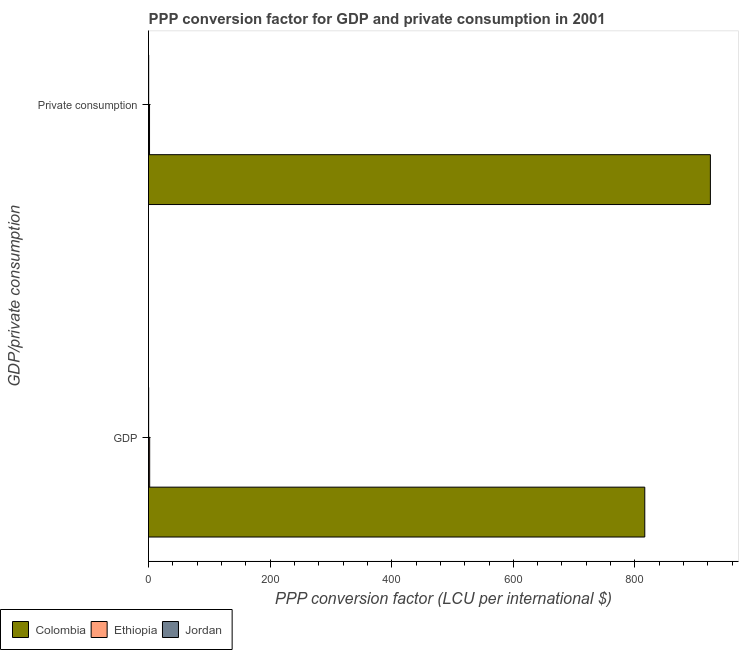Are the number of bars on each tick of the Y-axis equal?
Give a very brief answer. Yes. What is the label of the 1st group of bars from the top?
Provide a succinct answer.  Private consumption. What is the ppp conversion factor for gdp in Ethiopia?
Ensure brevity in your answer.  1.9. Across all countries, what is the maximum ppp conversion factor for private consumption?
Your response must be concise. 924.15. Across all countries, what is the minimum ppp conversion factor for gdp?
Your response must be concise. 0.2. In which country was the ppp conversion factor for private consumption minimum?
Give a very brief answer. Jordan. What is the total ppp conversion factor for private consumption in the graph?
Make the answer very short. 926.08. What is the difference between the ppp conversion factor for gdp in Colombia and that in Ethiopia?
Give a very brief answer. 814.32. What is the difference between the ppp conversion factor for private consumption in Ethiopia and the ppp conversion factor for gdp in Colombia?
Keep it short and to the point. -814.56. What is the average ppp conversion factor for private consumption per country?
Provide a short and direct response. 308.69. What is the difference between the ppp conversion factor for private consumption and ppp conversion factor for gdp in Ethiopia?
Your answer should be compact. -0.23. In how many countries, is the ppp conversion factor for private consumption greater than 600 LCU?
Your answer should be very brief. 1. What is the ratio of the ppp conversion factor for gdp in Ethiopia to that in Colombia?
Your answer should be very brief. 0. Is the ppp conversion factor for private consumption in Jordan less than that in Colombia?
Offer a very short reply. Yes. In how many countries, is the ppp conversion factor for gdp greater than the average ppp conversion factor for gdp taken over all countries?
Make the answer very short. 1. What does the 1st bar from the top in GDP represents?
Your answer should be very brief. Jordan. What does the 1st bar from the bottom in  Private consumption represents?
Your response must be concise. Colombia. How many bars are there?
Your answer should be very brief. 6. Are all the bars in the graph horizontal?
Your response must be concise. Yes. How many countries are there in the graph?
Your answer should be compact. 3. What is the difference between two consecutive major ticks on the X-axis?
Your answer should be compact. 200. Are the values on the major ticks of X-axis written in scientific E-notation?
Make the answer very short. No. Does the graph contain any zero values?
Ensure brevity in your answer.  No. Does the graph contain grids?
Offer a very short reply. No. Where does the legend appear in the graph?
Provide a short and direct response. Bottom left. What is the title of the graph?
Offer a very short reply. PPP conversion factor for GDP and private consumption in 2001. Does "Namibia" appear as one of the legend labels in the graph?
Give a very brief answer. No. What is the label or title of the X-axis?
Make the answer very short. PPP conversion factor (LCU per international $). What is the label or title of the Y-axis?
Your answer should be very brief. GDP/private consumption. What is the PPP conversion factor (LCU per international $) in Colombia in GDP?
Provide a succinct answer. 816.22. What is the PPP conversion factor (LCU per international $) in Ethiopia in GDP?
Provide a short and direct response. 1.9. What is the PPP conversion factor (LCU per international $) of Jordan in GDP?
Provide a succinct answer. 0.2. What is the PPP conversion factor (LCU per international $) of Colombia in  Private consumption?
Keep it short and to the point. 924.15. What is the PPP conversion factor (LCU per international $) in Ethiopia in  Private consumption?
Offer a terse response. 1.67. What is the PPP conversion factor (LCU per international $) of Jordan in  Private consumption?
Make the answer very short. 0.26. Across all GDP/private consumption, what is the maximum PPP conversion factor (LCU per international $) in Colombia?
Ensure brevity in your answer.  924.15. Across all GDP/private consumption, what is the maximum PPP conversion factor (LCU per international $) in Ethiopia?
Your answer should be compact. 1.9. Across all GDP/private consumption, what is the maximum PPP conversion factor (LCU per international $) of Jordan?
Your answer should be very brief. 0.26. Across all GDP/private consumption, what is the minimum PPP conversion factor (LCU per international $) in Colombia?
Keep it short and to the point. 816.22. Across all GDP/private consumption, what is the minimum PPP conversion factor (LCU per international $) of Ethiopia?
Offer a very short reply. 1.67. Across all GDP/private consumption, what is the minimum PPP conversion factor (LCU per international $) of Jordan?
Provide a short and direct response. 0.2. What is the total PPP conversion factor (LCU per international $) of Colombia in the graph?
Provide a short and direct response. 1740.37. What is the total PPP conversion factor (LCU per international $) of Ethiopia in the graph?
Your answer should be compact. 3.56. What is the total PPP conversion factor (LCU per international $) of Jordan in the graph?
Your response must be concise. 0.46. What is the difference between the PPP conversion factor (LCU per international $) of Colombia in GDP and that in  Private consumption?
Your answer should be compact. -107.93. What is the difference between the PPP conversion factor (LCU per international $) in Ethiopia in GDP and that in  Private consumption?
Offer a very short reply. 0.23. What is the difference between the PPP conversion factor (LCU per international $) in Jordan in GDP and that in  Private consumption?
Ensure brevity in your answer.  -0.06. What is the difference between the PPP conversion factor (LCU per international $) in Colombia in GDP and the PPP conversion factor (LCU per international $) in Ethiopia in  Private consumption?
Your answer should be compact. 814.56. What is the difference between the PPP conversion factor (LCU per international $) in Colombia in GDP and the PPP conversion factor (LCU per international $) in Jordan in  Private consumption?
Keep it short and to the point. 815.96. What is the difference between the PPP conversion factor (LCU per international $) in Ethiopia in GDP and the PPP conversion factor (LCU per international $) in Jordan in  Private consumption?
Keep it short and to the point. 1.64. What is the average PPP conversion factor (LCU per international $) of Colombia per GDP/private consumption?
Offer a terse response. 870.19. What is the average PPP conversion factor (LCU per international $) of Ethiopia per GDP/private consumption?
Provide a short and direct response. 1.78. What is the average PPP conversion factor (LCU per international $) in Jordan per GDP/private consumption?
Offer a very short reply. 0.23. What is the difference between the PPP conversion factor (LCU per international $) in Colombia and PPP conversion factor (LCU per international $) in Ethiopia in GDP?
Provide a succinct answer. 814.32. What is the difference between the PPP conversion factor (LCU per international $) in Colombia and PPP conversion factor (LCU per international $) in Jordan in GDP?
Make the answer very short. 816.02. What is the difference between the PPP conversion factor (LCU per international $) of Ethiopia and PPP conversion factor (LCU per international $) of Jordan in GDP?
Your answer should be compact. 1.7. What is the difference between the PPP conversion factor (LCU per international $) of Colombia and PPP conversion factor (LCU per international $) of Ethiopia in  Private consumption?
Ensure brevity in your answer.  922.49. What is the difference between the PPP conversion factor (LCU per international $) in Colombia and PPP conversion factor (LCU per international $) in Jordan in  Private consumption?
Keep it short and to the point. 923.89. What is the difference between the PPP conversion factor (LCU per international $) in Ethiopia and PPP conversion factor (LCU per international $) in Jordan in  Private consumption?
Ensure brevity in your answer.  1.4. What is the ratio of the PPP conversion factor (LCU per international $) in Colombia in GDP to that in  Private consumption?
Your answer should be very brief. 0.88. What is the ratio of the PPP conversion factor (LCU per international $) in Ethiopia in GDP to that in  Private consumption?
Your answer should be compact. 1.14. What is the ratio of the PPP conversion factor (LCU per international $) of Jordan in GDP to that in  Private consumption?
Ensure brevity in your answer.  0.77. What is the difference between the highest and the second highest PPP conversion factor (LCU per international $) of Colombia?
Provide a short and direct response. 107.93. What is the difference between the highest and the second highest PPP conversion factor (LCU per international $) in Ethiopia?
Provide a short and direct response. 0.23. What is the difference between the highest and the second highest PPP conversion factor (LCU per international $) of Jordan?
Ensure brevity in your answer.  0.06. What is the difference between the highest and the lowest PPP conversion factor (LCU per international $) in Colombia?
Your answer should be compact. 107.93. What is the difference between the highest and the lowest PPP conversion factor (LCU per international $) of Ethiopia?
Your answer should be compact. 0.23. What is the difference between the highest and the lowest PPP conversion factor (LCU per international $) of Jordan?
Your response must be concise. 0.06. 